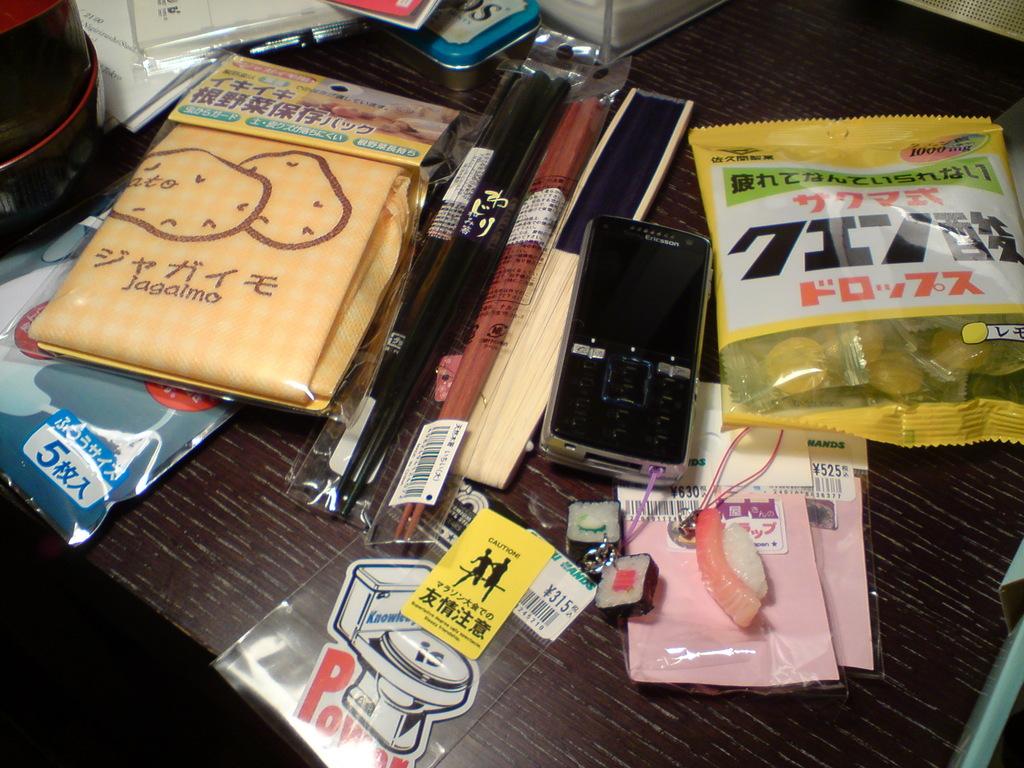Is that the word power with a toilet on top of it sticker?
Your answer should be compact. Yes. 